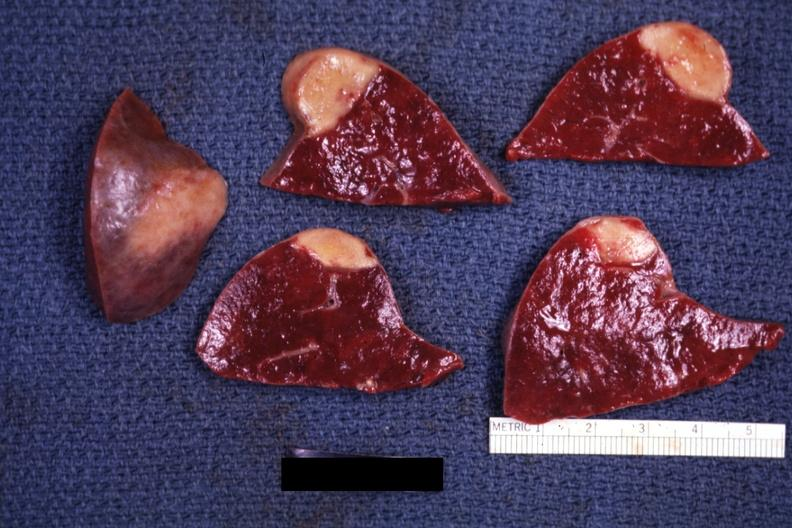s infarct present?
Answer the question using a single word or phrase. Yes 